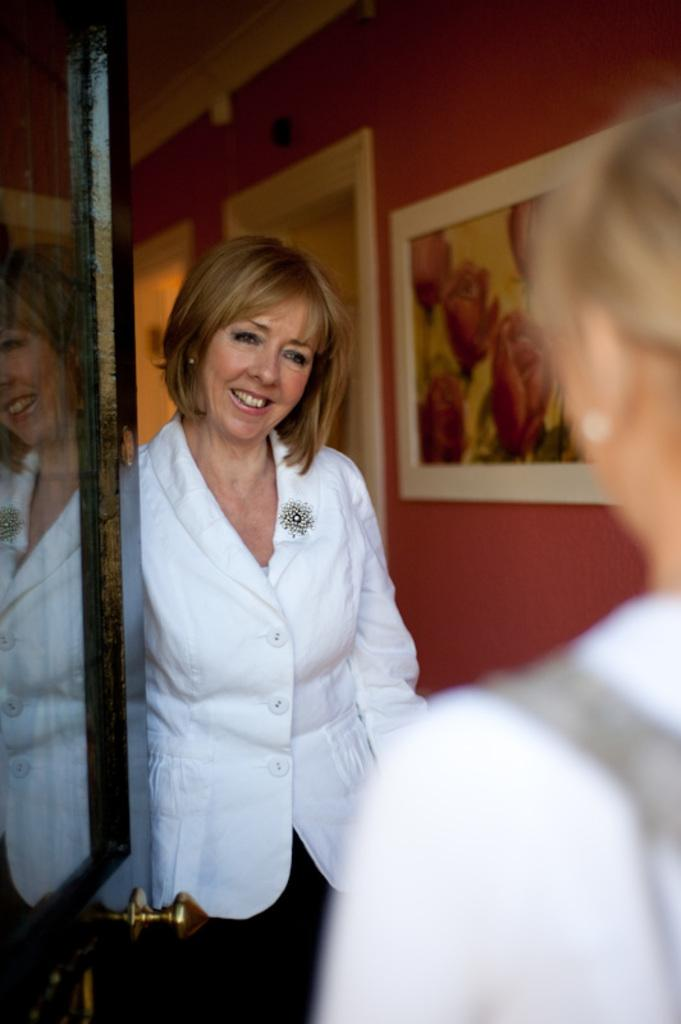Who is the main subject in the image? There is a lady in the center of the image. What can be seen on the left side of the image? There is a door on the left side of the image. Are there any other people in the image besides the lady in the center? Yes, there is another lady on the right side of the image. What is the health condition of the lady driving a car in the image? There is no lady driving a car in the image, and therefore no information about her health condition can be provided. 